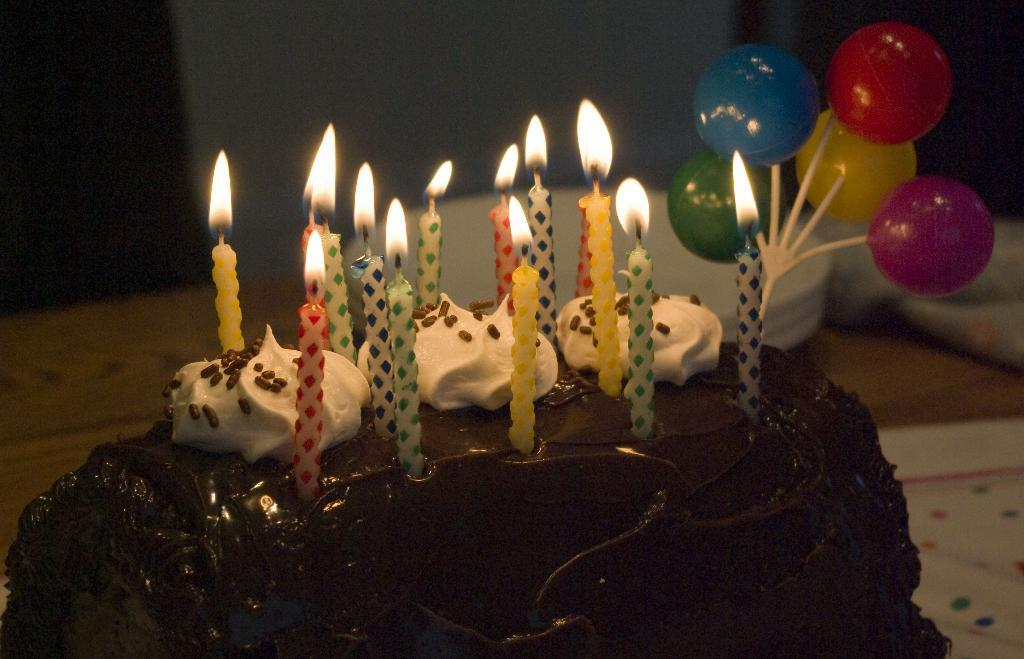What type of cake is shown in the image? There is a chocolate cake in the image. Are there any decorations on the cake? Yes, there are candles on the cake. What other object is present in the image besides the cake? There is a toy with some balls in the image. How would you describe the background of the cake? The background of the cake is blurred. How does the cake aid in the digestion process? The image does not provide information about the cake's effect on digestion, as it only shows the cake's appearance. 